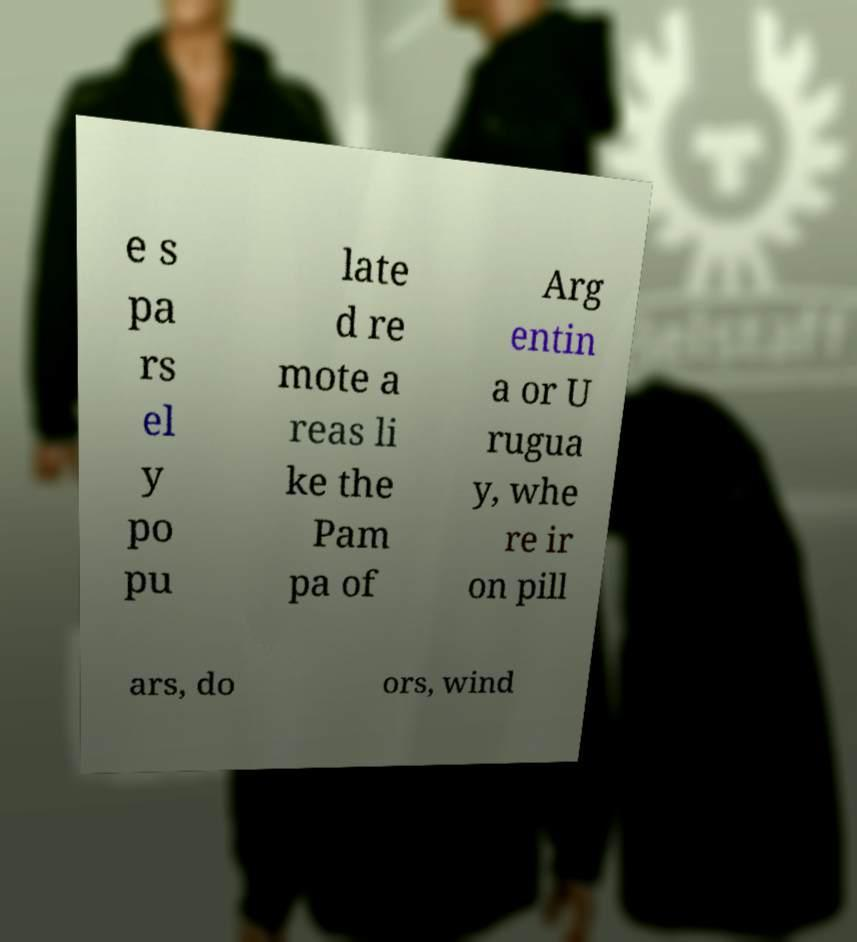What messages or text are displayed in this image? I need them in a readable, typed format. e s pa rs el y po pu late d re mote a reas li ke the Pam pa of Arg entin a or U rugua y, whe re ir on pill ars, do ors, wind 